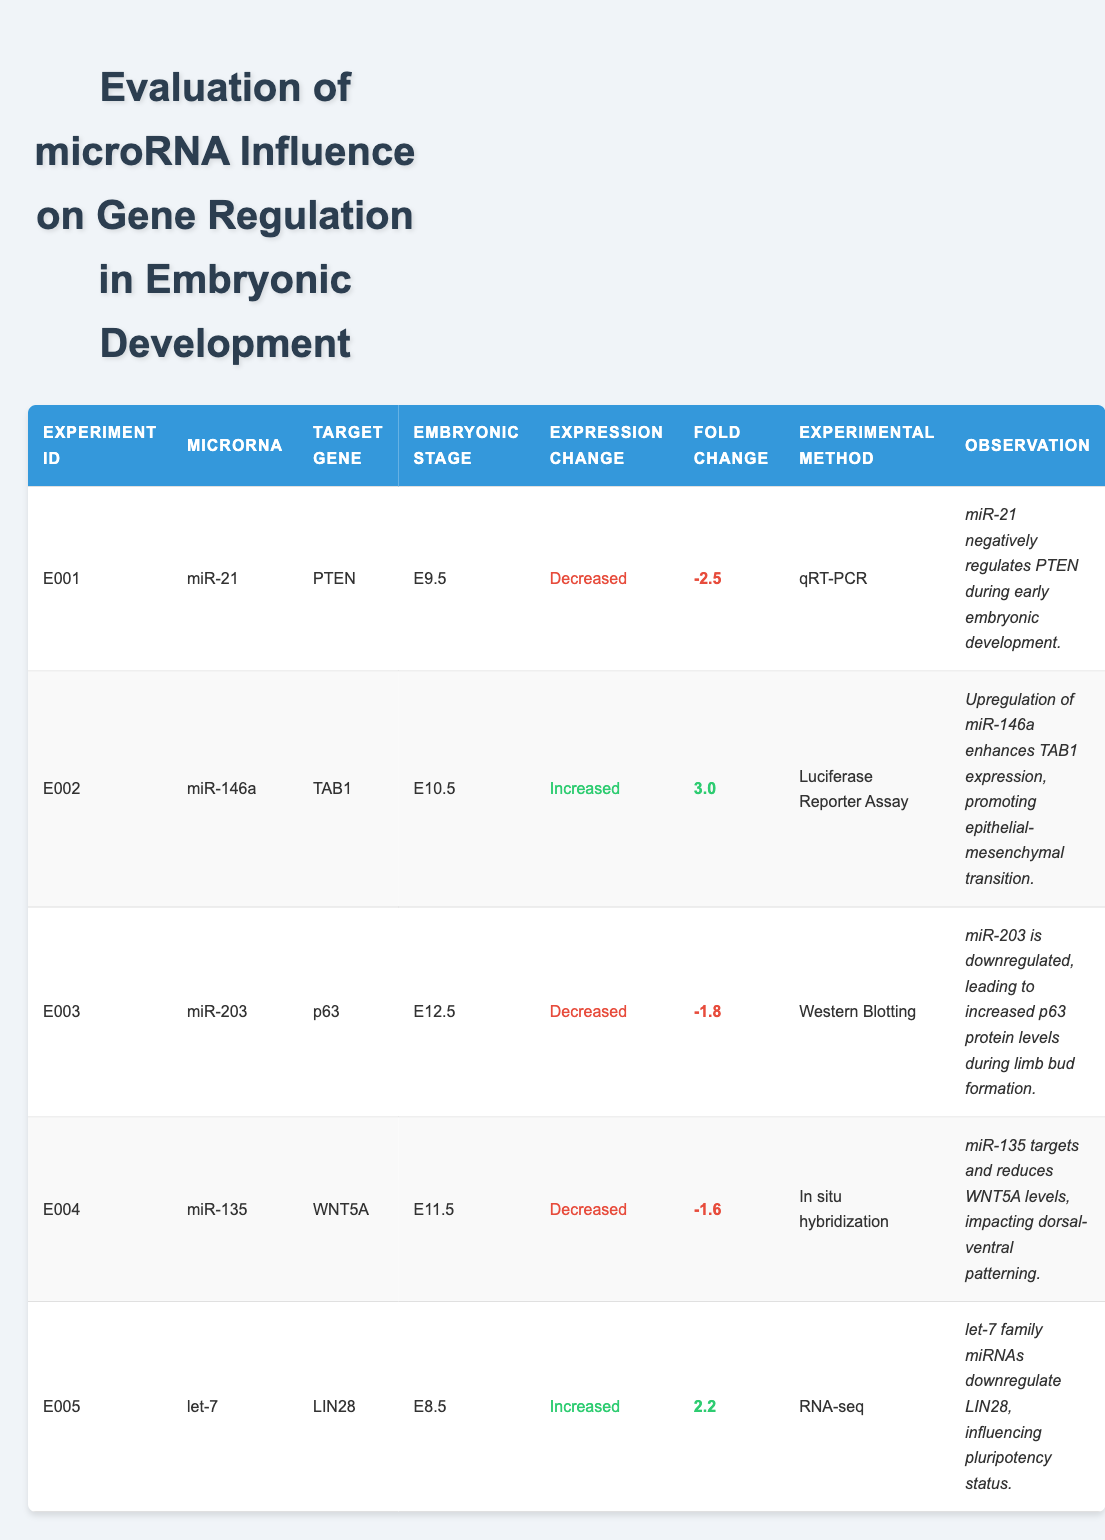What is the target gene of miR-21 in experiment E001? The table lists the target gene for each microRNA in the relevant columns. For experiment E001, the microRNA is miR-21 and the corresponding target gene is PTEN.
Answer: PTEN Which microRNA was tested at the embryonic stage E10.5? By reviewing the embryonic stage column, we find that miR-146a corresponds to the embryonic stage E10.5 in experiment E002.
Answer: miR-146a How many microRNAs in the table are associated with an increased expression change? The expression change column shows which microRNAs are linked to increased expression. miR-146a (E002) and let-7 (E005) are the only ones listed with increased expression, totaling two microRNAs.
Answer: 2 Is it true that miR-203 increases the expression of its target gene? The expression change for miR-203 in experiment E003 shows it is decreased. Since a negative regulation indicates a decrease in expression, the statement is false.
Answer: False What is the average fold change of the microRNAs that decrease expression? We observe the fold change values for microRNAs with decreased expression: -2.5 (miR-21), -1.8 (miR-203), and -1.6 (miR-135). The average is calculated as: (-2.5 + -1.8 + -1.6) / 3 = -2.3 so the average fold change is -2.3.
Answer: -2.3 What observation is associated with miR-146a in experiment E002? The observation for miR-146a in the observation column mentions that its upregulation enhances TAB1 expression and promotes epithelial-mesenchymal transition.
Answer: Upregulation enhances TAB1 expression promoting epithelial-mesenchymal transition How many experimental methods are represented in the experiments? By examining the experimental method column, we count distinct methods used: qRT-PCR, Luciferase Reporter Assay, Western Blotting, In situ hybridization, and RNA-seq. That totals five different experimental methods used.
Answer: 5 Which microRNA has the highest fold change? Looking at the fold change values, miR-146a from experiment E002 shows the highest positive fold change at 3.0.
Answer: miR-146a What is the relationship between miR-135 and WNT5A based on the observations? The observation for miR-135 in experiment E004 indicates it targets and reduces WNT5A levels, implicating a negative influence on WNT5A expression.
Answer: miR-135 negatively influences WNT5A 